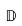Convert formula to latex. <formula><loc_0><loc_0><loc_500><loc_500>\mathbb { D }</formula> 